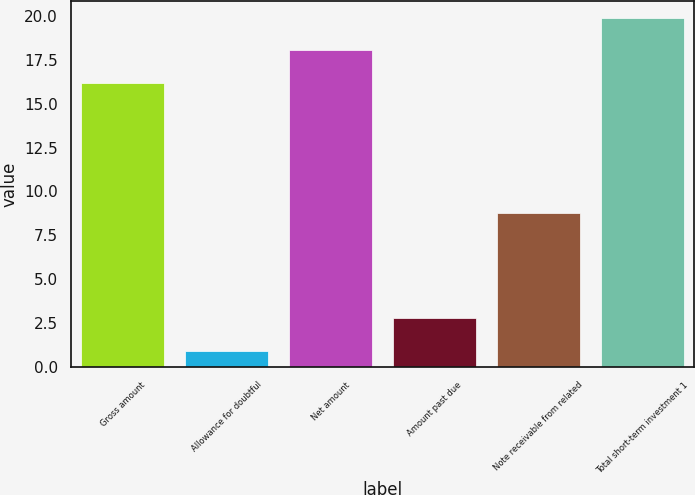Convert chart to OTSL. <chart><loc_0><loc_0><loc_500><loc_500><bar_chart><fcel>Gross amount<fcel>Allowance for doubtful<fcel>Net amount<fcel>Amount past due<fcel>Note receivable from related<fcel>Total short-term investment 1<nl><fcel>16.2<fcel>0.94<fcel>18.03<fcel>2.77<fcel>8.8<fcel>19.86<nl></chart> 